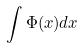Convert formula to latex. <formula><loc_0><loc_0><loc_500><loc_500>\int \Phi ( x ) d x</formula> 